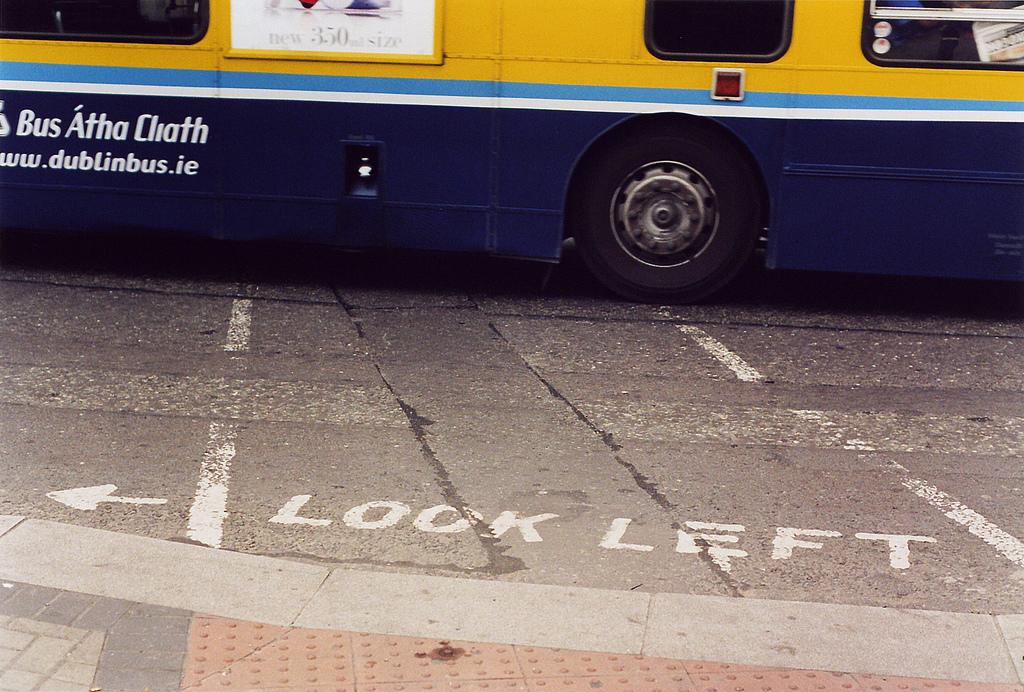What is in the foreground of the image? There is a road in the foreground of the image. What is written on the road? There is text on the road. What can be seen in the background of the image? There is a bus in the background of the image. Where is the bus located in relation to the road? The bus is on the road. What type of windows are visible at the top of the image? There are glass windows visible at the top of the image. How much tax is being paid by the sea in the image? There is no sea present in the image, and therefore no tax can be paid by it. What type of nerve is visible in the image? There are no nerves visible in the image; it features a road, text, a bus, and glass windows. 